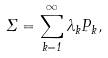<formula> <loc_0><loc_0><loc_500><loc_500>\Sigma = \sum _ { k = 1 } ^ { \infty } \lambda _ { k } P _ { k } ,</formula> 